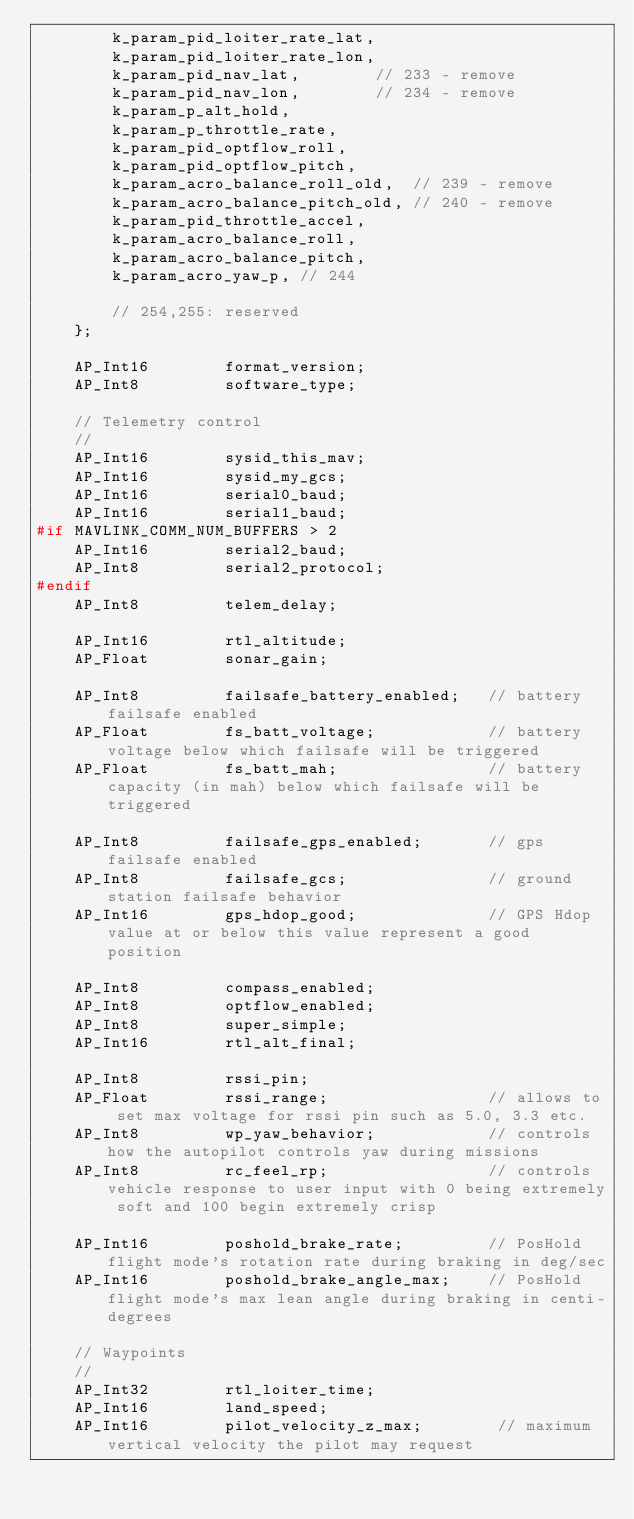Convert code to text. <code><loc_0><loc_0><loc_500><loc_500><_C_>        k_param_pid_loiter_rate_lat,
        k_param_pid_loiter_rate_lon,
        k_param_pid_nav_lat,        // 233 - remove
        k_param_pid_nav_lon,        // 234 - remove
        k_param_p_alt_hold,
        k_param_p_throttle_rate,
        k_param_pid_optflow_roll,
        k_param_pid_optflow_pitch,
        k_param_acro_balance_roll_old,  // 239 - remove
        k_param_acro_balance_pitch_old, // 240 - remove
        k_param_pid_throttle_accel,
        k_param_acro_balance_roll,
        k_param_acro_balance_pitch,
        k_param_acro_yaw_p, // 244

        // 254,255: reserved
    };

    AP_Int16        format_version;
    AP_Int8         software_type;

    // Telemetry control
    //
    AP_Int16        sysid_this_mav;
    AP_Int16        sysid_my_gcs;
    AP_Int16        serial0_baud;
    AP_Int16        serial1_baud;
#if MAVLINK_COMM_NUM_BUFFERS > 2
    AP_Int16        serial2_baud;
    AP_Int8         serial2_protocol;
#endif
    AP_Int8         telem_delay;

    AP_Int16        rtl_altitude;
    AP_Float        sonar_gain;

    AP_Int8         failsafe_battery_enabled;   // battery failsafe enabled
    AP_Float        fs_batt_voltage;            // battery voltage below which failsafe will be triggered
    AP_Float        fs_batt_mah;                // battery capacity (in mah) below which failsafe will be triggered

    AP_Int8         failsafe_gps_enabled;       // gps failsafe enabled
    AP_Int8         failsafe_gcs;               // ground station failsafe behavior
    AP_Int16        gps_hdop_good;              // GPS Hdop value at or below this value represent a good position

    AP_Int8         compass_enabled;
    AP_Int8         optflow_enabled;
    AP_Int8         super_simple;
    AP_Int16        rtl_alt_final;

    AP_Int8         rssi_pin;
    AP_Float        rssi_range;                 // allows to set max voltage for rssi pin such as 5.0, 3.3 etc. 
    AP_Int8         wp_yaw_behavior;            // controls how the autopilot controls yaw during missions
    AP_Int8         rc_feel_rp;                 // controls vehicle response to user input with 0 being extremely soft and 100 begin extremely crisp

    AP_Int16        poshold_brake_rate;         // PosHold flight mode's rotation rate during braking in deg/sec
    AP_Int16        poshold_brake_angle_max;    // PosHold flight mode's max lean angle during braking in centi-degrees
    
    // Waypoints
    //
    AP_Int32        rtl_loiter_time;
    AP_Int16        land_speed;
    AP_Int16        pilot_velocity_z_max;        // maximum vertical velocity the pilot may request</code> 